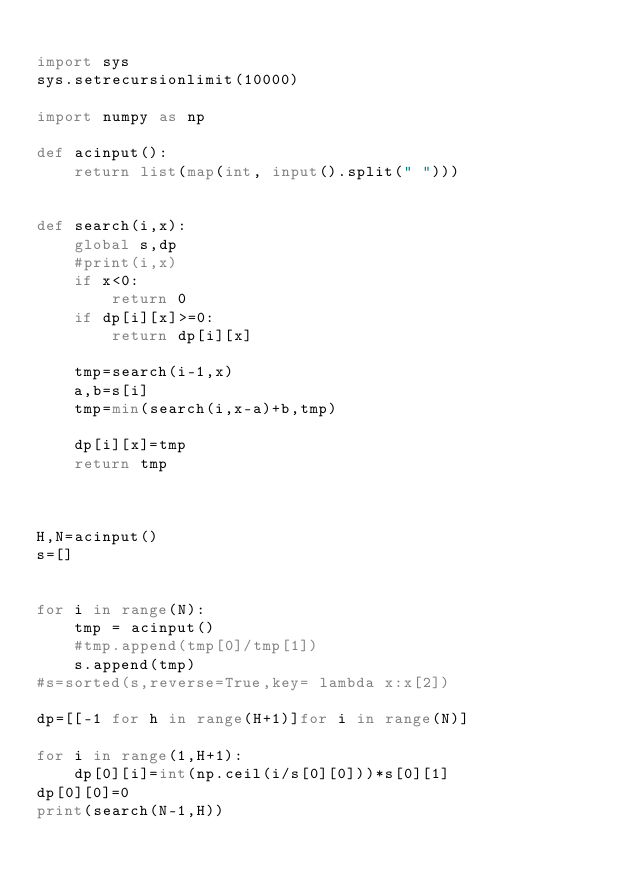Convert code to text. <code><loc_0><loc_0><loc_500><loc_500><_Python_>
import sys
sys.setrecursionlimit(10000)

import numpy as np

def acinput():
    return list(map(int, input().split(" ")))


def search(i,x):
    global s,dp
    #print(i,x)
    if x<0:
        return 0
    if dp[i][x]>=0:
        return dp[i][x]
    
    tmp=search(i-1,x)
    a,b=s[i]
    tmp=min(search(i,x-a)+b,tmp)
        
    dp[i][x]=tmp
    return tmp



H,N=acinput()
s=[]


for i in range(N):
    tmp = acinput()
    #tmp.append(tmp[0]/tmp[1])
    s.append(tmp)    
#s=sorted(s,reverse=True,key= lambda x:x[2])

dp=[[-1 for h in range(H+1)]for i in range(N)]

for i in range(1,H+1):
    dp[0][i]=int(np.ceil(i/s[0][0]))*s[0][1]
dp[0][0]=0
print(search(N-1,H))
</code> 